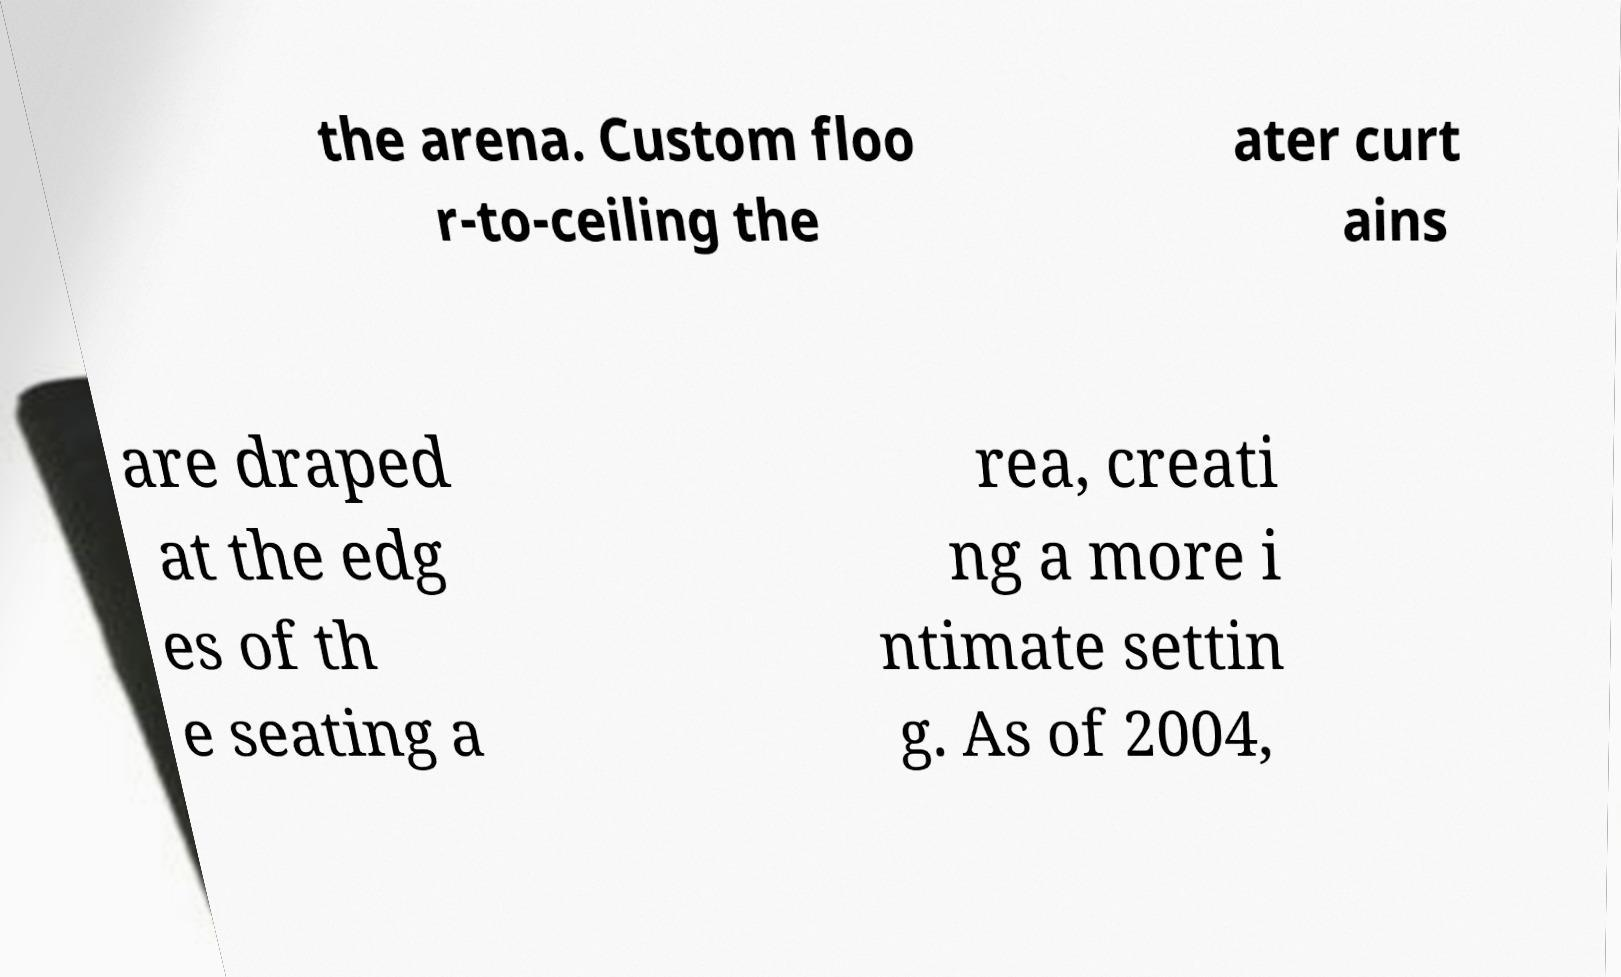Can you accurately transcribe the text from the provided image for me? the arena. Custom floo r-to-ceiling the ater curt ains are draped at the edg es of th e seating a rea, creati ng a more i ntimate settin g. As of 2004, 